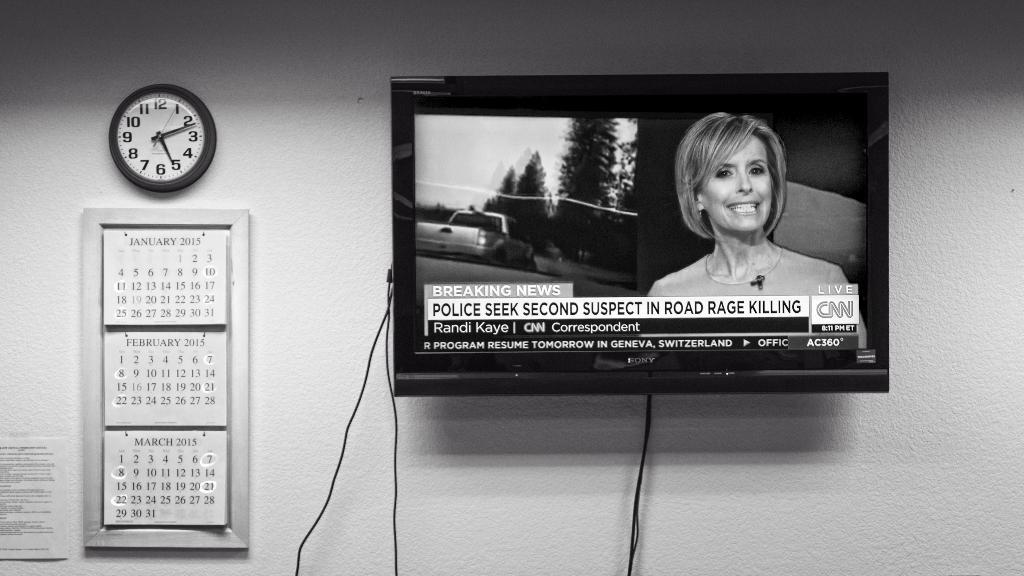<image>
Write a terse but informative summary of the picture. A clock next to a CNN breaking news story shows the time as 5:10 